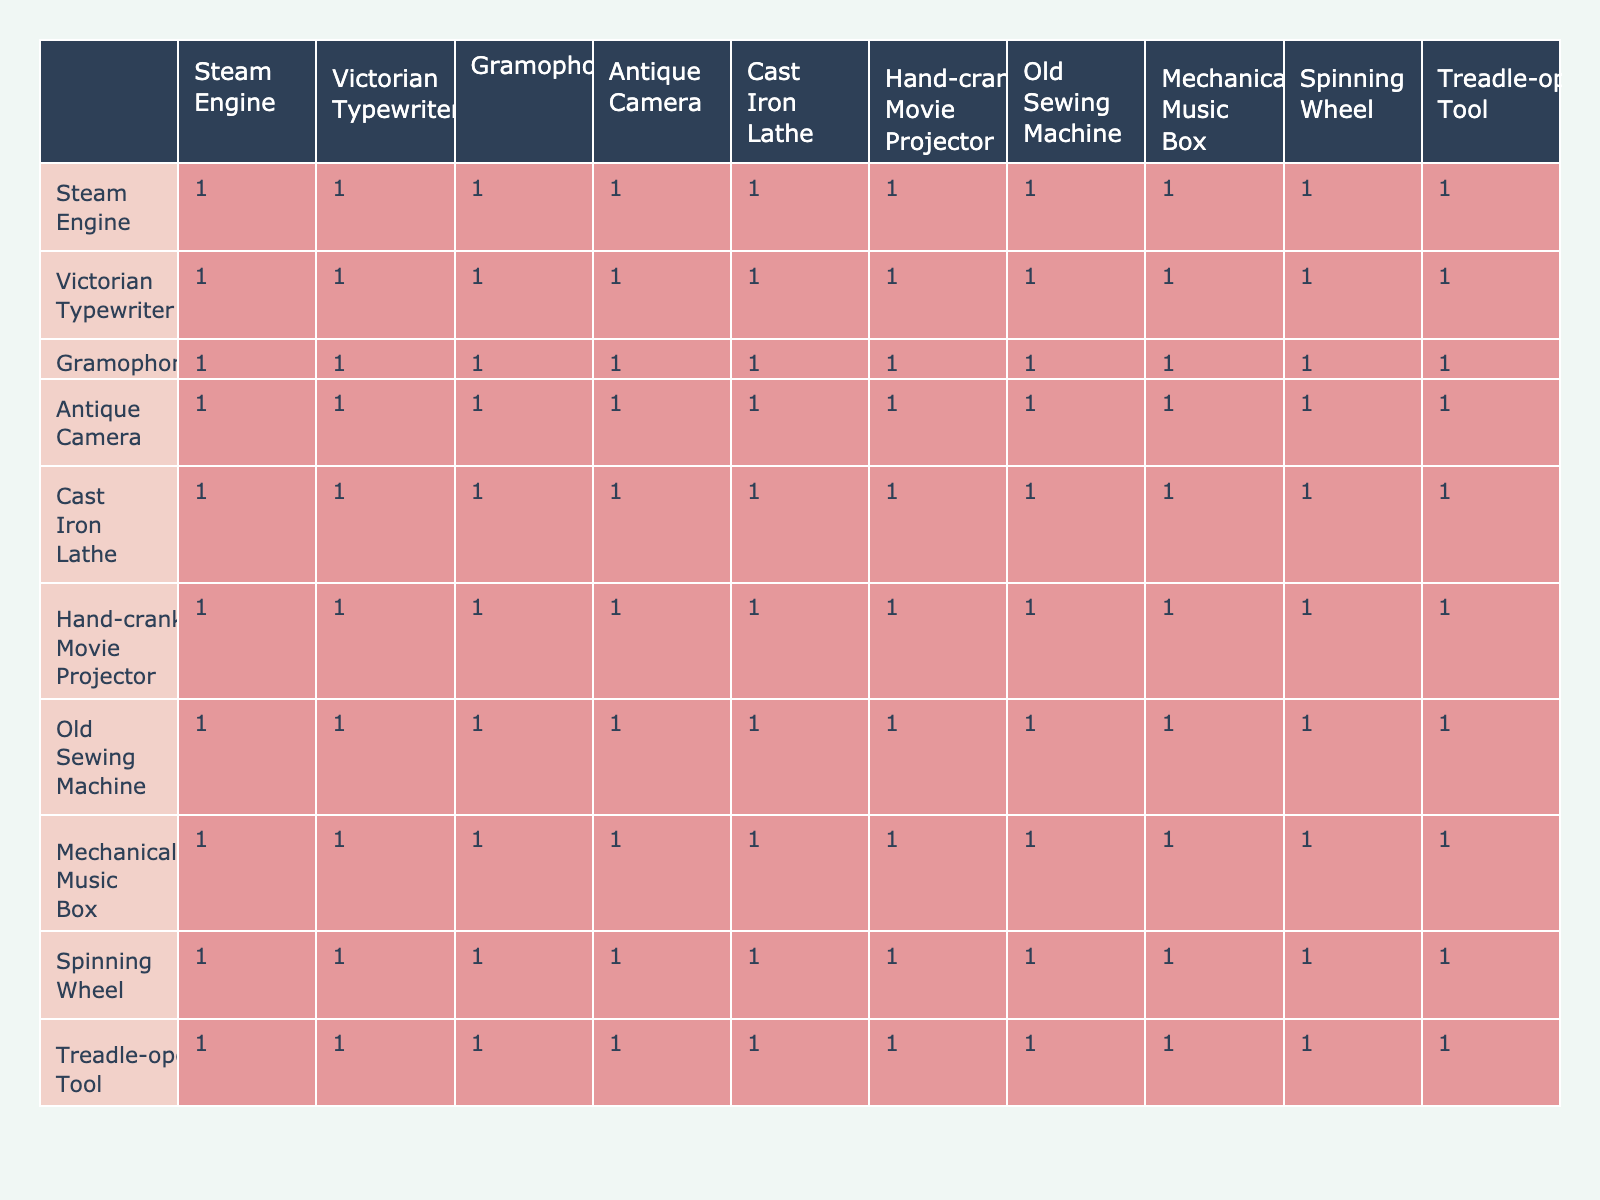What is the frequency of maintenance required for a Gramophone? From the table, the Gramophone has a frequency of maintenance required of 3 times per year, as explicitly listed under the "Frequency of Maintenance Required" column.
Answer: 3 How many types of machinery require maintenance more than 3 times per year? By inspecting the table, we can identify that the Steam Engine (5) and Cast Iron Lathe (4) both require maintenance more than 3 times per year. Therefore, there are a total of 2 types of machinery that meet this criterion.
Answer: 2 Is it true that a Mechanical Music Box requires only one maintenance session per year? The table shows that the Mechanical Music Box has a maintenance frequency of 1 per year. Thus, the statement is true based on the data provided.
Answer: Yes What is the average frequency of maintenance required across all the antique machinery listed? To calculate the average, sum all maintenance frequencies: (5 + 2 + 3 + 2 + 4 + 3 + 2 + 1 + 2 + 4) = 28. There are 10 types of machinery, so the average frequency is 28/10 = 2.8.
Answer: 2.8 Which type of antique machinery requires the highest frequency of maintenance? According to the table, the Steam Engine requires the most maintenance at 5 times per year which is higher than any other listed machinery.
Answer: Steam Engine How much more frequently does the Treadle-operated Tool require maintenance compared to the Mechanical Music Box? The Treadle-operated Tool requires maintenance 4 times per year while the Mechanical Music Box requires it only once. The difference is 4 - 1 = 3.
Answer: 3 Are there any machinery types that require maintenance less than 2 times per year? Reviewing the table, the only machinery that requires maintenance less than 2 times per year is the Mechanical Music Box, which requires it just once. Therefore, the answer is yes.
Answer: Yes If you were to group the machinery by maintenance frequency of 2 or less, how many would fall into that category? Within the table, the machinery types that require maintenance of 2 or less are the Mechanical Music Box (1), Victorian Typewriter (2), Antique Camera (2), Old Sewing Machine (2), and Spinning Wheel (2). In total, there are 5 types of machinery in this category.
Answer: 5 